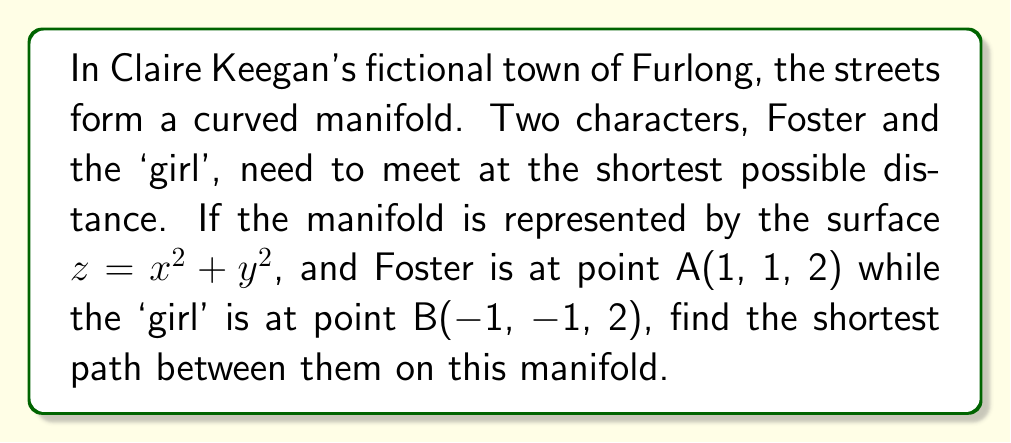Give your solution to this math problem. To find the shortest path between two points on a manifold, we need to use the concept of geodesics. In this case, we're dealing with a paraboloid surface.

1) First, we parameterize the surface. Let $\mathbf{r}(u,v) = (u, v, u^2 + v^2)$ be our parameterization.

2) Next, we calculate the metric tensor $g_{ij}$:

   $g_{11} = 1 + 4u^2$
   $g_{12} = g_{21} = 4uv$
   $g_{22} = 1 + 4v^2$

3) The geodesic equations are:

   $$\frac{d^2u}{dt^2} + \Gamma^1_{11}(\frac{du}{dt})^2 + 2\Gamma^1_{12}\frac{du}{dt}\frac{dv}{dt} + \Gamma^1_{22}(\frac{dv}{dt})^2 = 0$$
   $$\frac{d^2v}{dt^2} + \Gamma^2_{11}(\frac{du}{dt})^2 + 2\Gamma^2_{12}\frac{du}{dt}\frac{dv}{dt} + \Gamma^2_{22}(\frac{dv}{dt})^2 = 0$$

   Where $\Gamma^i_{jk}$ are the Christoffel symbols.

4) Calculating the Christoffel symbols and substituting into the geodesic equations gives us a system of differential equations.

5) Solving this system of equations analytically is complex, so we would typically use numerical methods.

6) The boundary conditions are:
   $u(0) = 1, v(0) = 1$
   $u(1) = -1, v(1) = -1$

7) Using a numerical solver (like Runge-Kutta method), we can find the path $(u(t), v(t))$ that satisfies these equations and boundary conditions.

8) The length of this path, given by the integral:

   $$L = \int_0^1 \sqrt{g_{11}(\frac{du}{dt})^2 + 2g_{12}\frac{du}{dt}\frac{dv}{dt} + g_{22}(\frac{dv}{dt})^2} dt$$

   is the shortest distance between the points on the manifold.
Answer: The exact shortest path and its length would require numerical computation. However, we can say that the path will be a curved line on the paraboloid surface, not a straight line in 3D space. The length of this geodesic will be longer than the Euclidean distance between the points (which is $2\sqrt{3} \approx 3.46$), but shorter than the path along the surface that follows $u$ and $v$ coordinate lines. 